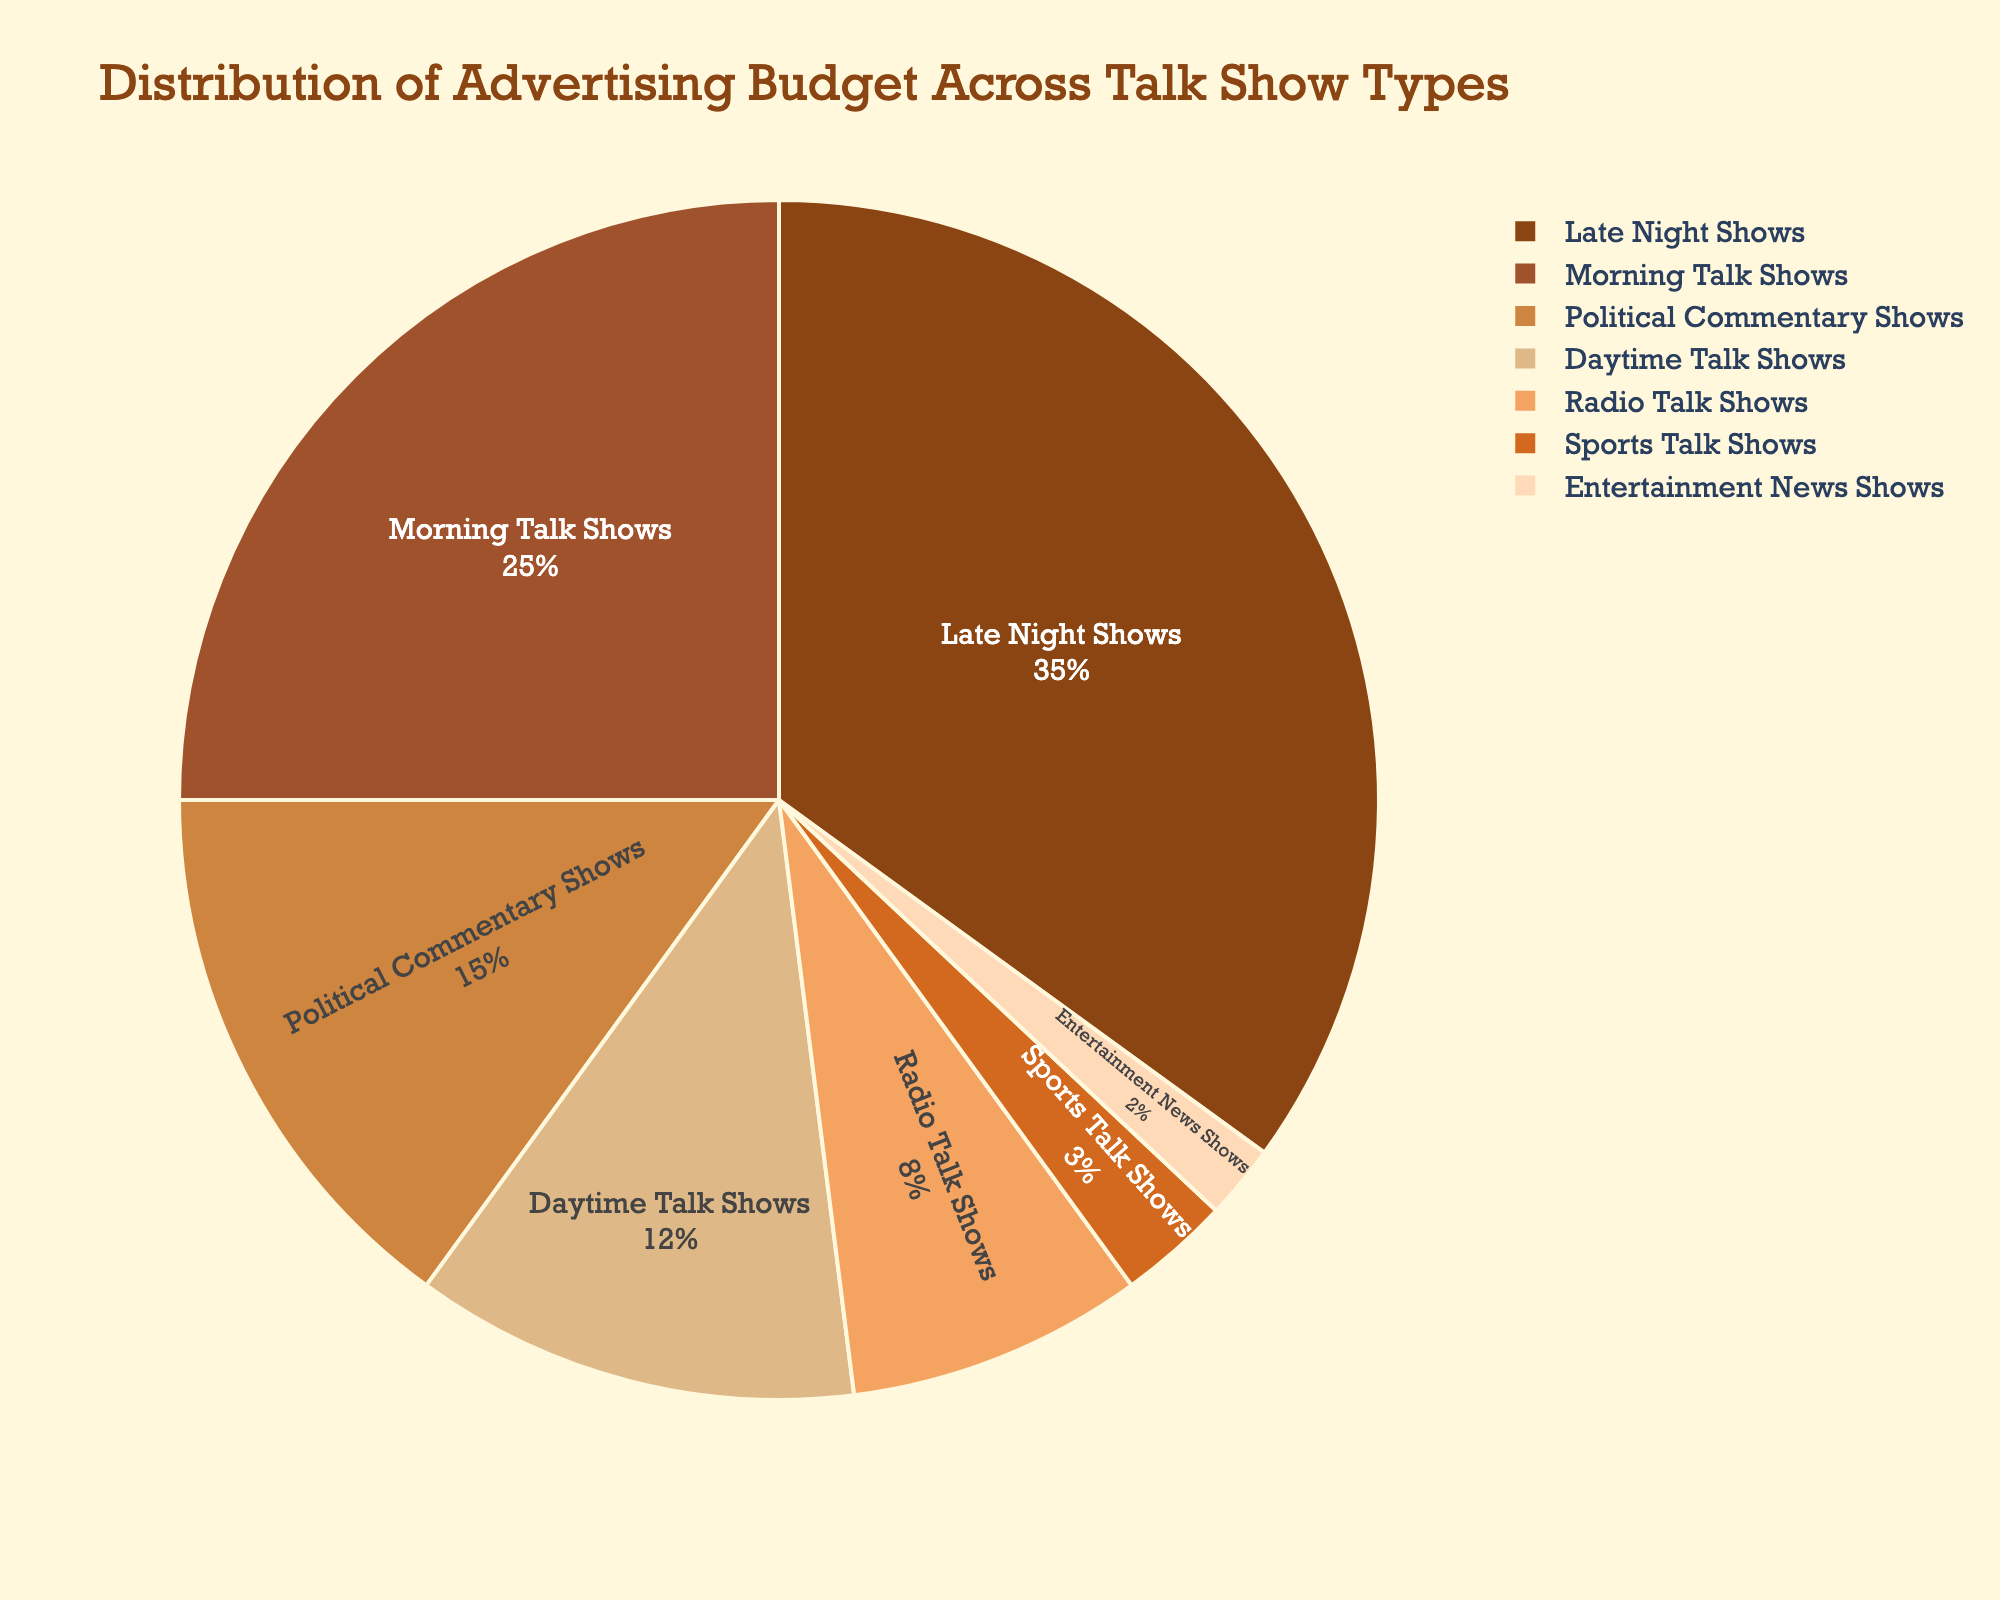What percentage of the advertising budget is allocated to late-night shows? Locate the label for "Late Night Shows" and refer to the number inside the pie slice. The percentage shown is 35%.
Answer: 35% How much larger is the budget percentage for late-night shows compared to daytime talk shows? Subtract the percentage of "Daytime Talk Shows" from "Late Night Shows" (35% - 12%). This gives the difference as 23%.
Answer: 23% What are the combined percentages for morning talk shows and political commentary shows? Add the percentages for "Morning Talk Shows" and "Political Commentary Shows" (25% + 15%). The total is 40%.
Answer: 40% Which talk show type has the smallest budget percentage? Find the smallest slice in the pie chart. "Entertainment News Shows" has the smallest percentage at 2%.
Answer: Entertainment News Shows How does the advertising budget percentage for sports talk shows compare to radio talk shows? Compare the percentages of "Sports Talk Shows" and "Radio Talk Shows" (3% vs. 8%). Sports talk shows have a smaller budget percentage.
Answer: Sports talk shows have a smaller budget percentage than radio talk shows Which three talk show types combined make up 50% of the budget? Identify the three largest percentages and check if their sum equals 50%. "Late Night Shows" (35%) + "Morning Talk Shows" (25%) are already 60%, so the next three must be "Morning Talk Shows" (25%), "Political Commentary Shows" (15%), and "Daytime Talk Shows" (12%) which equals 52%, the last valid choice would be the first trio "Late Night Shows" (35%) + "Political Commentary Shows" (15%) as it equals 50%.
Answer: Late Night Shows and Political Commentary Shows What is the average budget percentage for the three least funded talk show types? Add together "Entertainment News Shows" (2%), "Sports Talk Shows" (3%), and "Radio Talk Shows" (8%) then divide by three ((2 + 3 + 8)/3). The average is approximately 4.33%.
Answer: 4.33% What is the total budget percentage allocated to talk shows other than political commentary shows? Subtract the percentage for "Political Commentary Shows" (15%) from 100%. The remaining budget is 85%.
Answer: 85% Are there more resources devoted to morning talk shows or the combination of daytime and radio talk shows? Combine the percentages of "Daytime Talk Shows" (12%) and "Radio Talk Shows" (8%) which totals to 20%. Compare this with the "Morning Talk Shows" that have 25%. Morning talk shows receive more resources.
Answer: Morning talk shows If you wanted to reduce the budget for radio talk shows by half, what percentage would you reallocate? The current budget for "Radio Talk Shows" is 8%. Reducing it by half would be 4%. Therefore, 4% would be reallocated.
Answer: 4% 